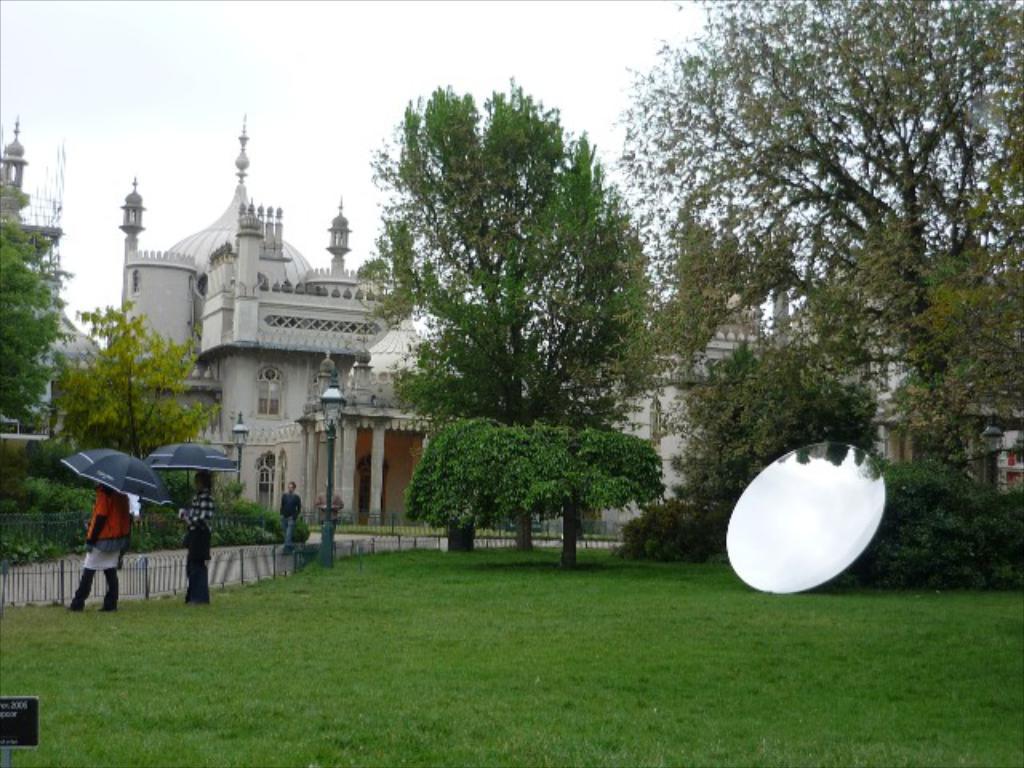In one or two sentences, can you explain what this image depicts? In the picture we can see lawn area, there is mirror, two persons standing and holding umbrellas in their hands, there are two persons walking through the walkway and in the background of the picture there are some trees, monuments and clear sky. 